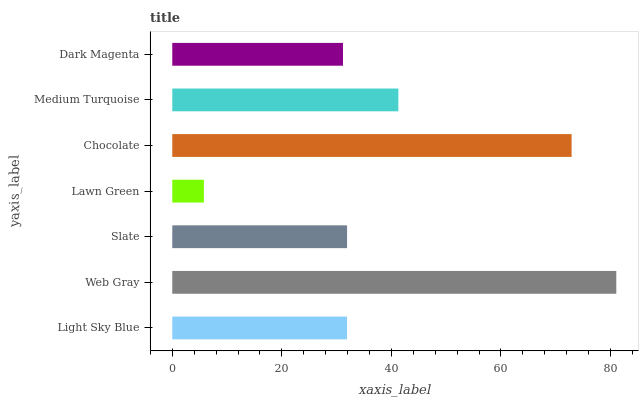Is Lawn Green the minimum?
Answer yes or no. Yes. Is Web Gray the maximum?
Answer yes or no. Yes. Is Slate the minimum?
Answer yes or no. No. Is Slate the maximum?
Answer yes or no. No. Is Web Gray greater than Slate?
Answer yes or no. Yes. Is Slate less than Web Gray?
Answer yes or no. Yes. Is Slate greater than Web Gray?
Answer yes or no. No. Is Web Gray less than Slate?
Answer yes or no. No. Is Slate the high median?
Answer yes or no. Yes. Is Slate the low median?
Answer yes or no. Yes. Is Chocolate the high median?
Answer yes or no. No. Is Medium Turquoise the low median?
Answer yes or no. No. 